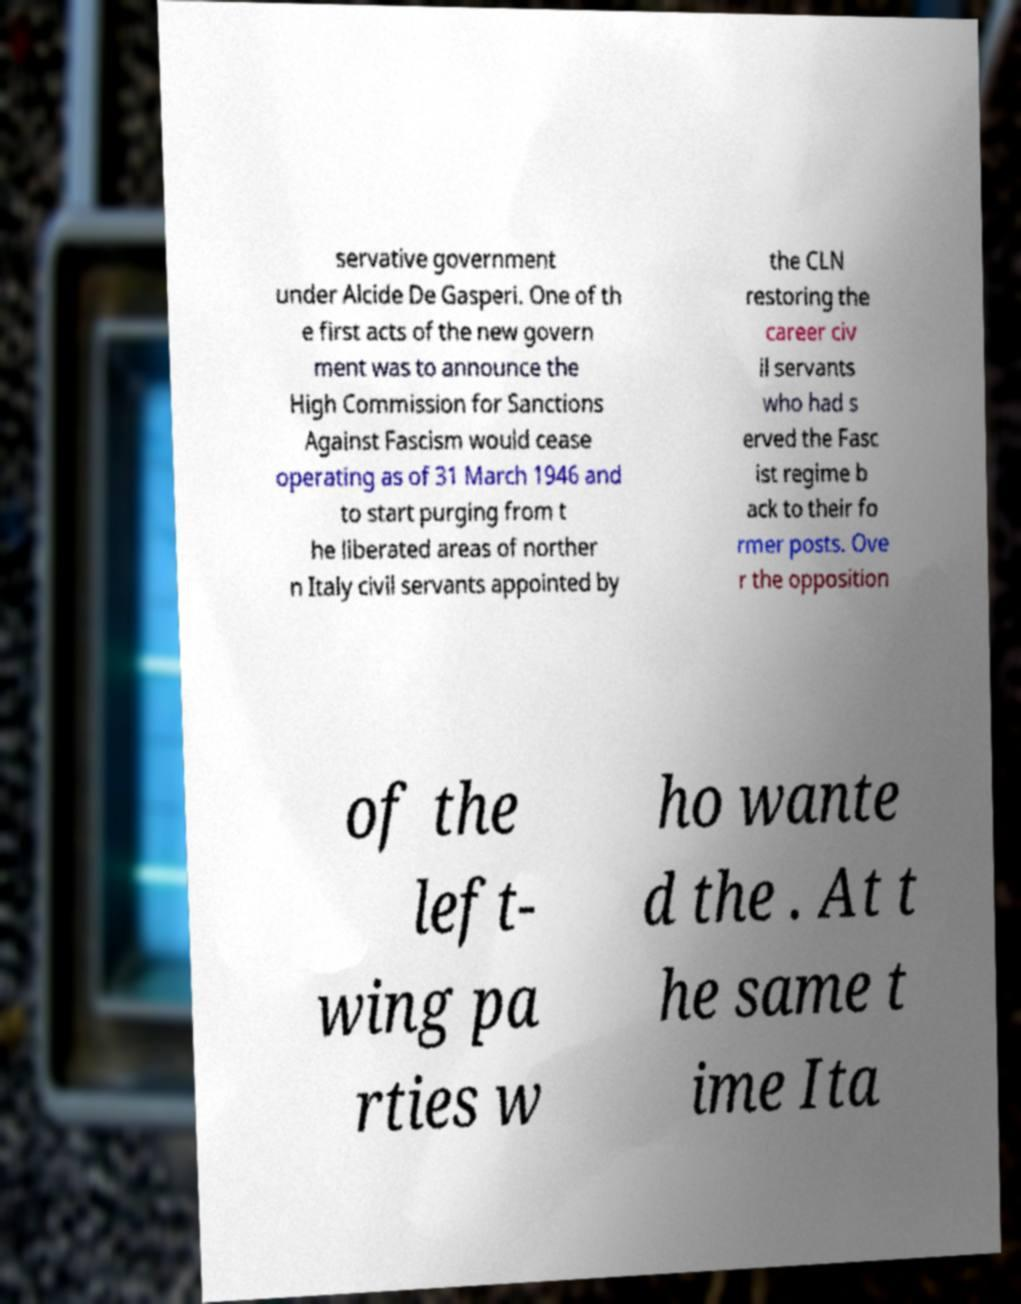I need the written content from this picture converted into text. Can you do that? servative government under Alcide De Gasperi. One of th e first acts of the new govern ment was to announce the High Commission for Sanctions Against Fascism would cease operating as of 31 March 1946 and to start purging from t he liberated areas of norther n Italy civil servants appointed by the CLN restoring the career civ il servants who had s erved the Fasc ist regime b ack to their fo rmer posts. Ove r the opposition of the left- wing pa rties w ho wante d the . At t he same t ime Ita 